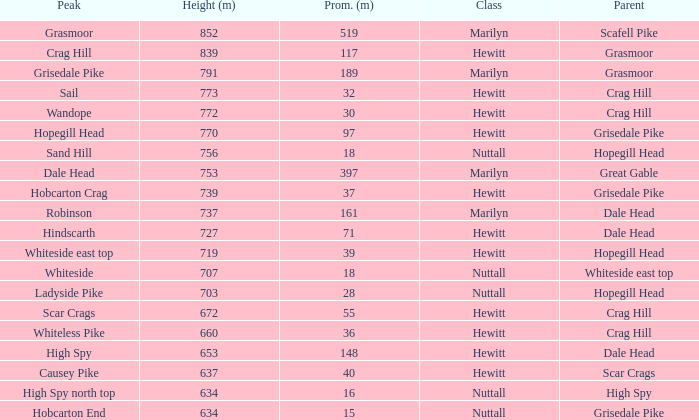Which Class is Peak Sail when it has a Prom larger than 30? Hewitt. 